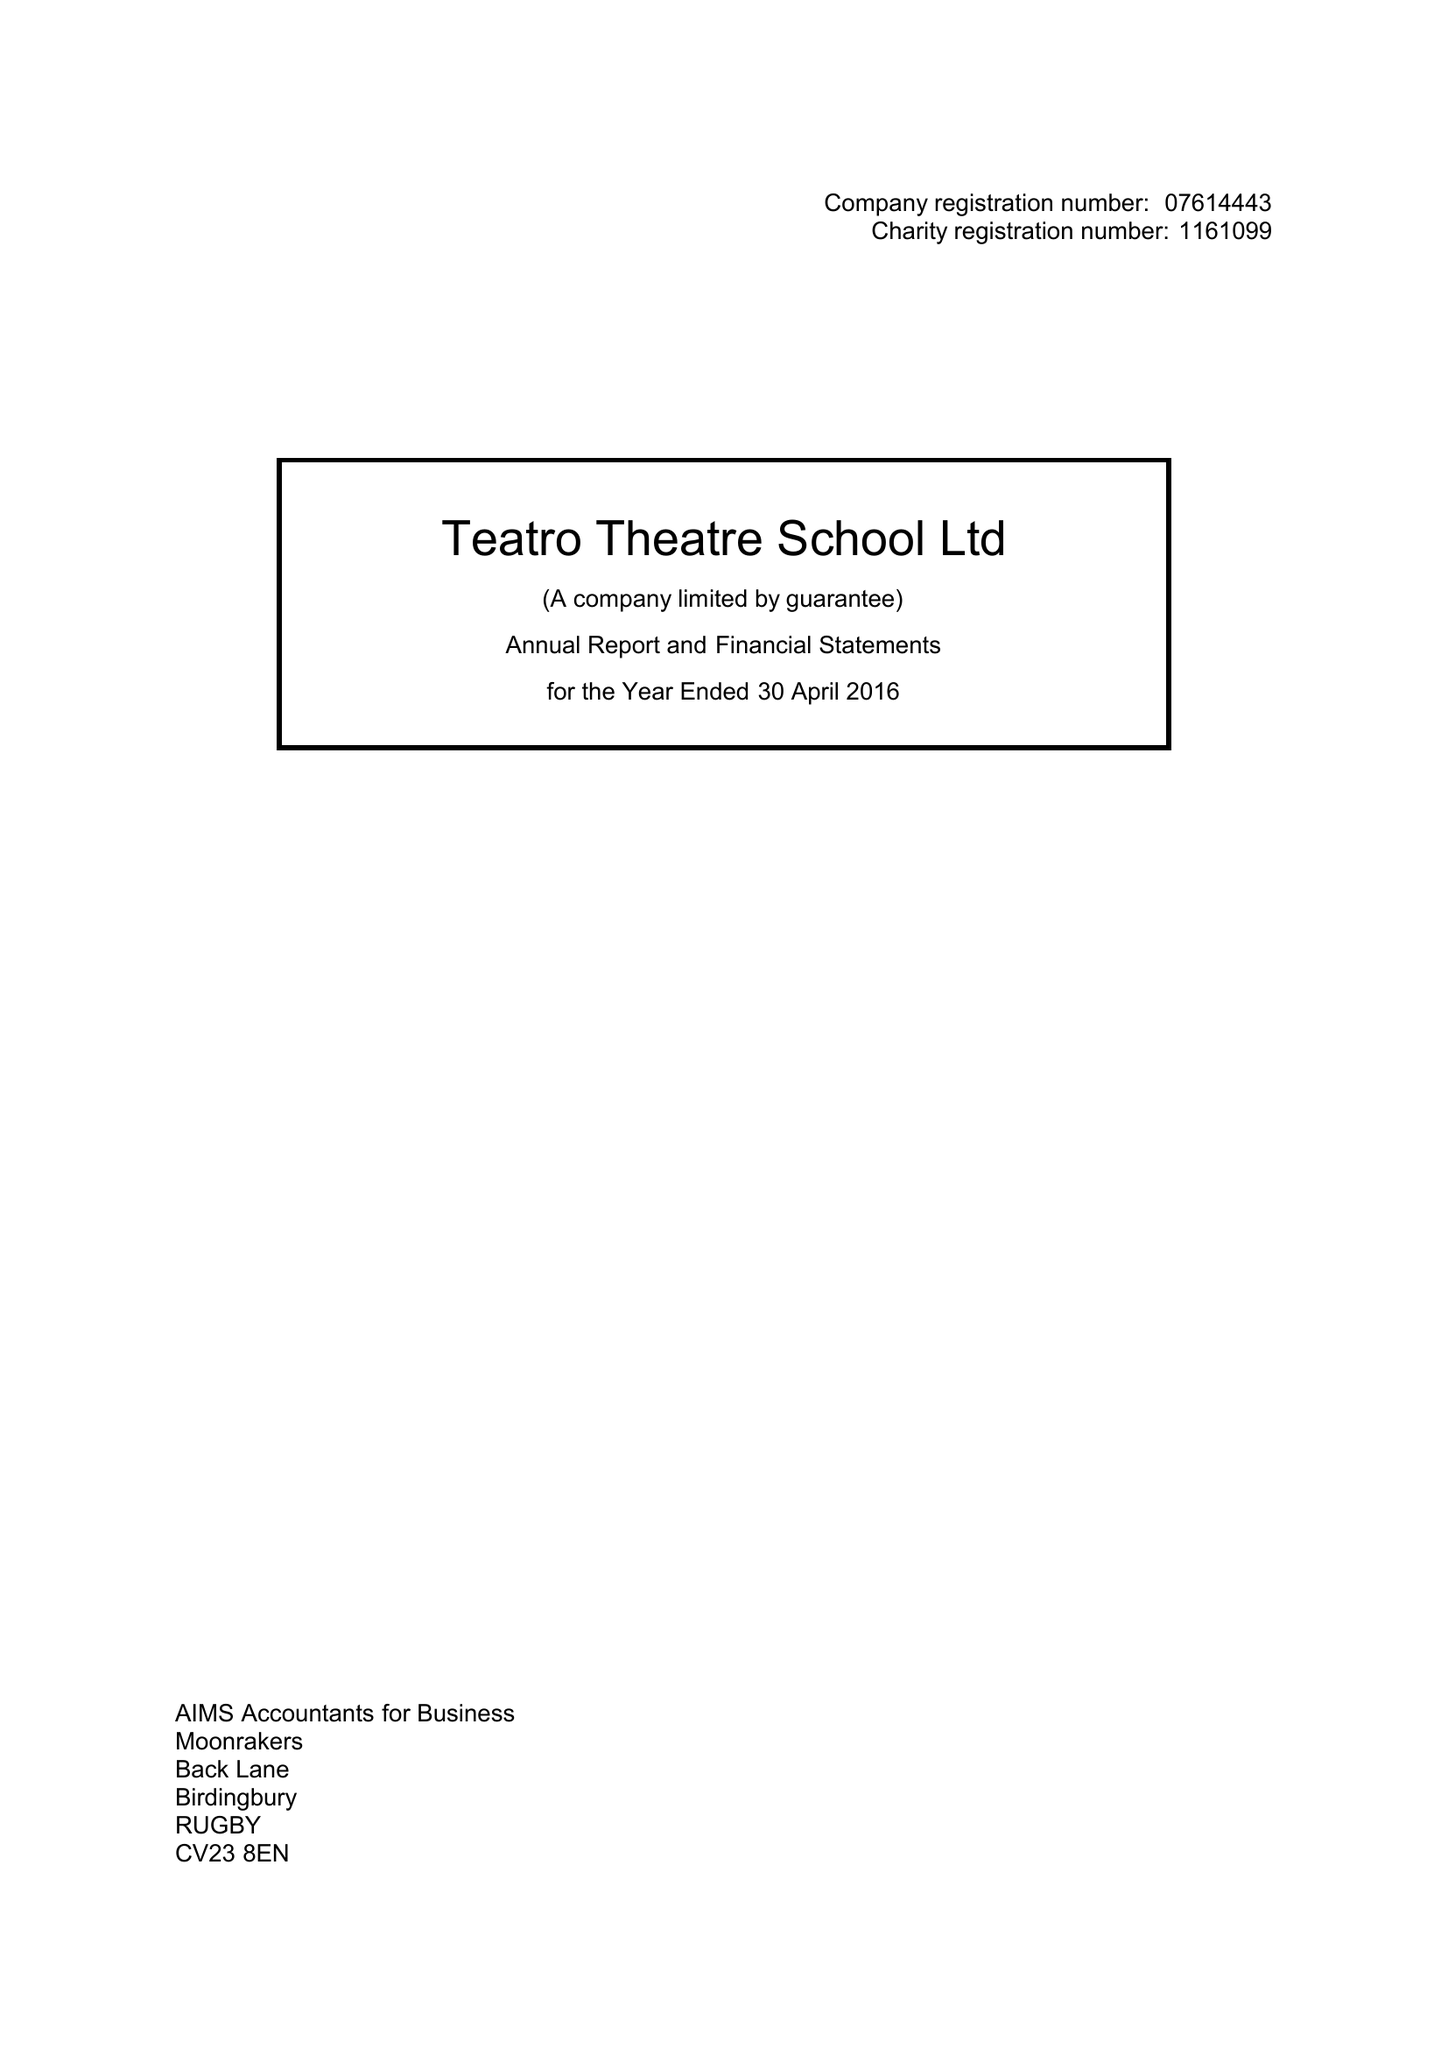What is the value for the spending_annually_in_british_pounds?
Answer the question using a single word or phrase. 23995.00 